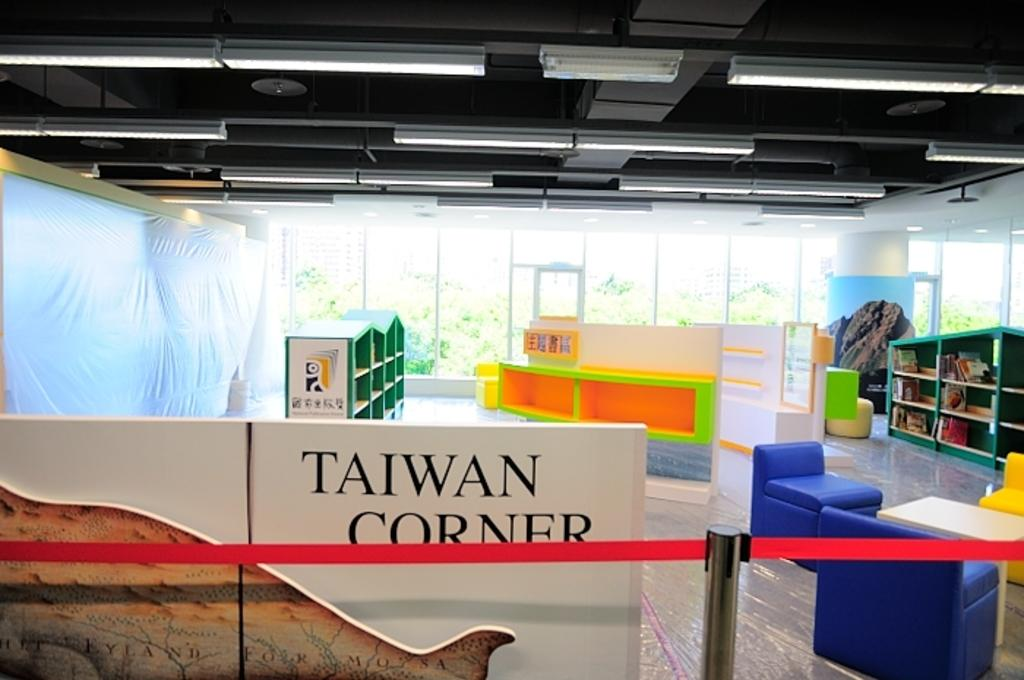<image>
Create a compact narrative representing the image presented. The inside of a library with a wall marked for the Taiwan corner. 